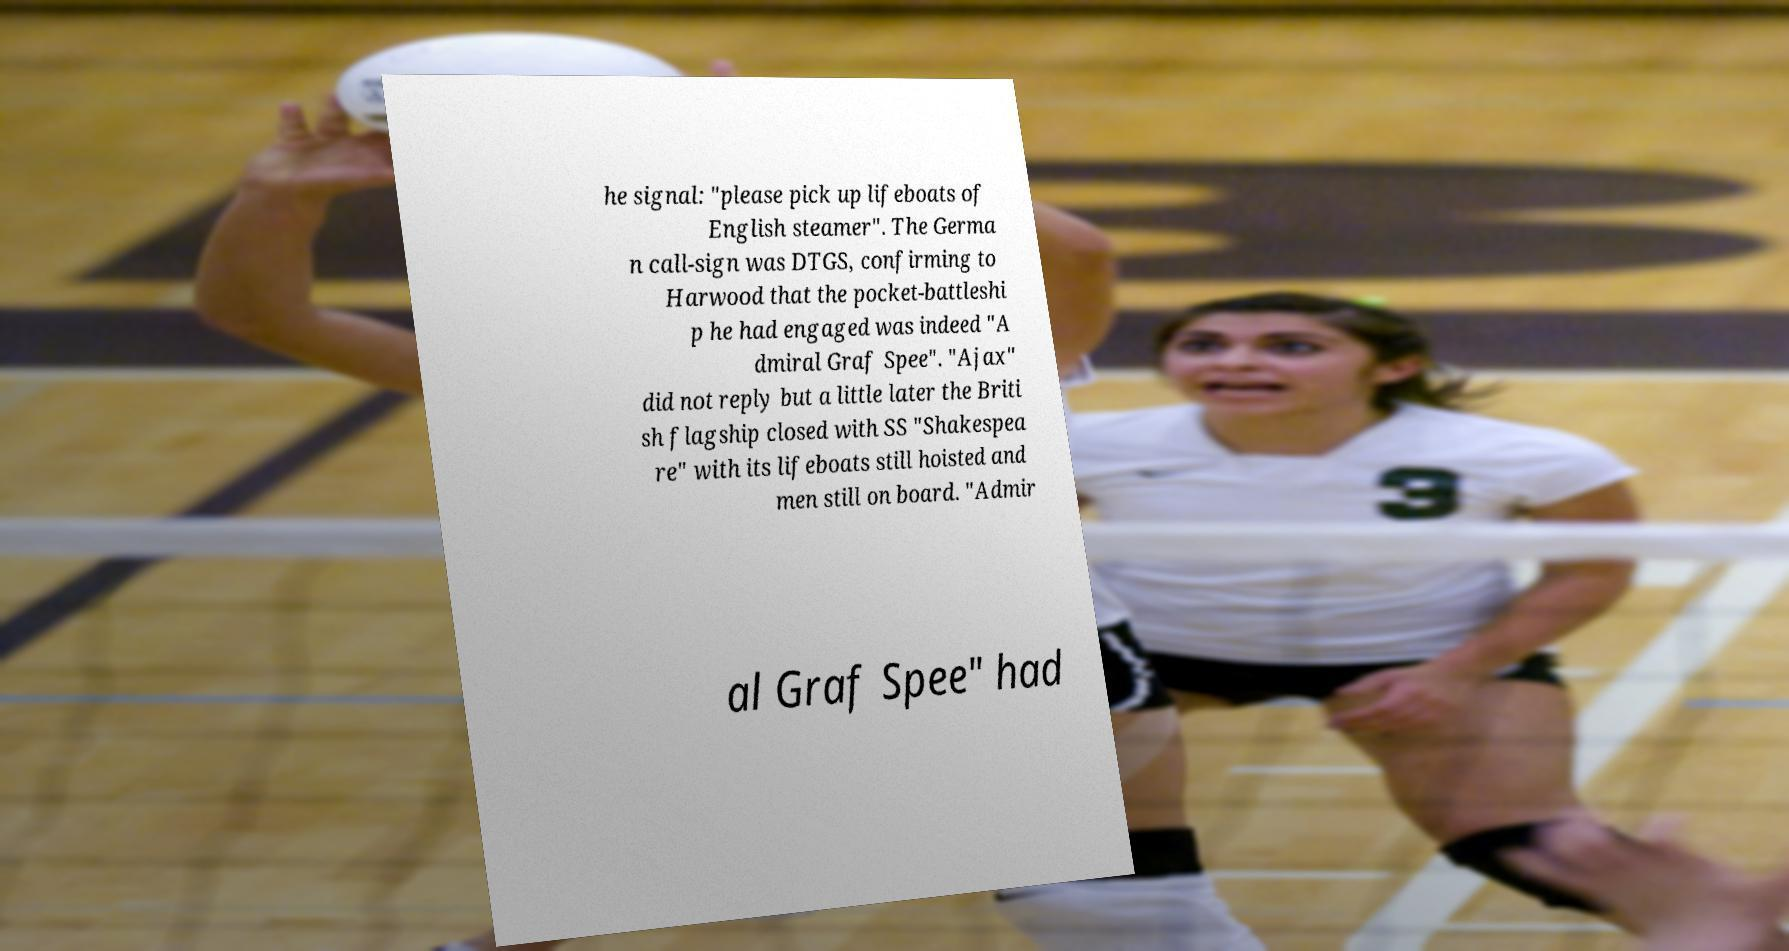I need the written content from this picture converted into text. Can you do that? he signal: "please pick up lifeboats of English steamer". The Germa n call-sign was DTGS, confirming to Harwood that the pocket-battleshi p he had engaged was indeed "A dmiral Graf Spee". "Ajax" did not reply but a little later the Briti sh flagship closed with SS "Shakespea re" with its lifeboats still hoisted and men still on board. "Admir al Graf Spee" had 